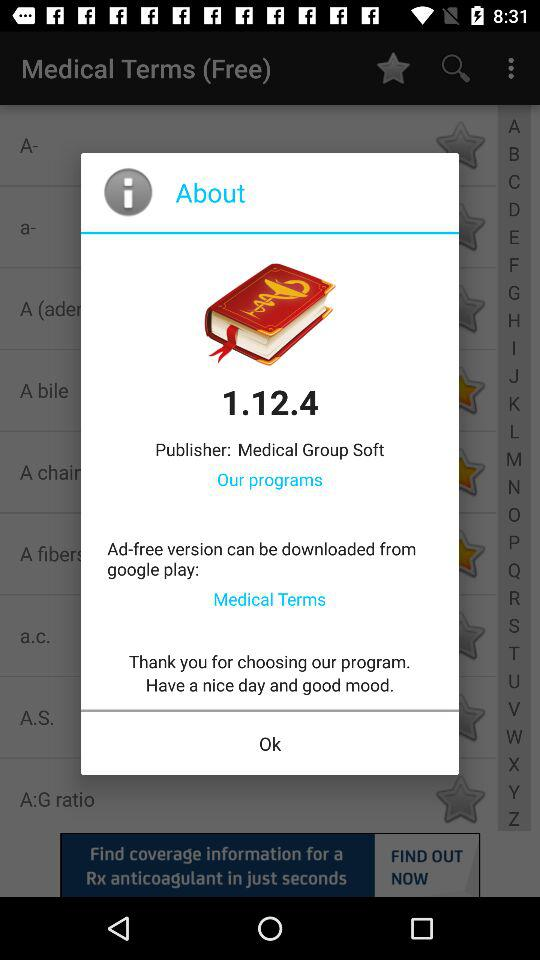What is the version of the application? The version of the application is 1.12.4. 